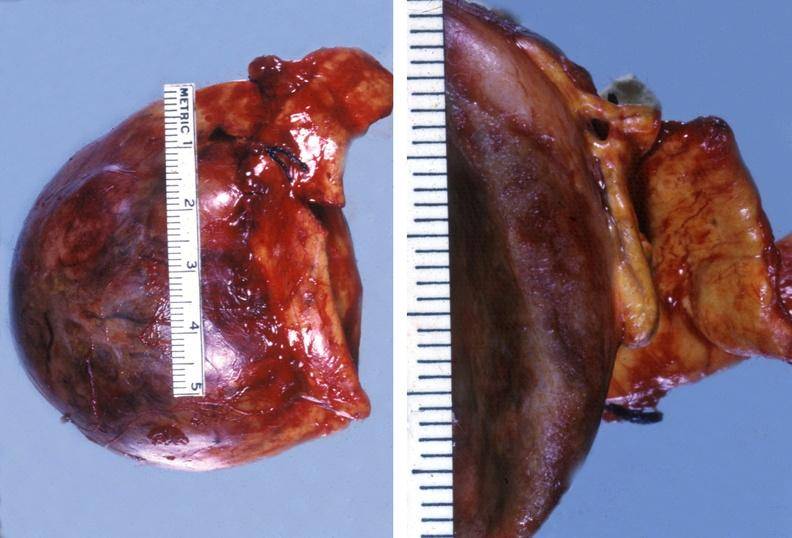where does this belong to?
Answer the question using a single word or phrase. Endocrine system 